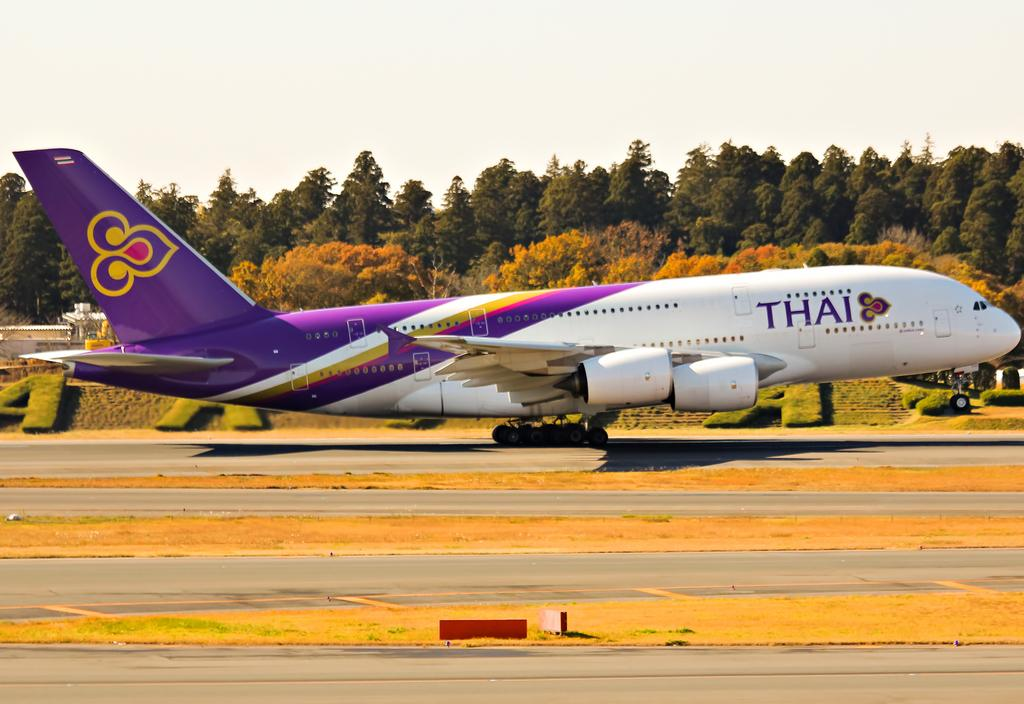<image>
Present a compact description of the photo's key features. a Thai airways airplane at take off from a runway 